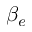Convert formula to latex. <formula><loc_0><loc_0><loc_500><loc_500>\beta _ { e }</formula> 